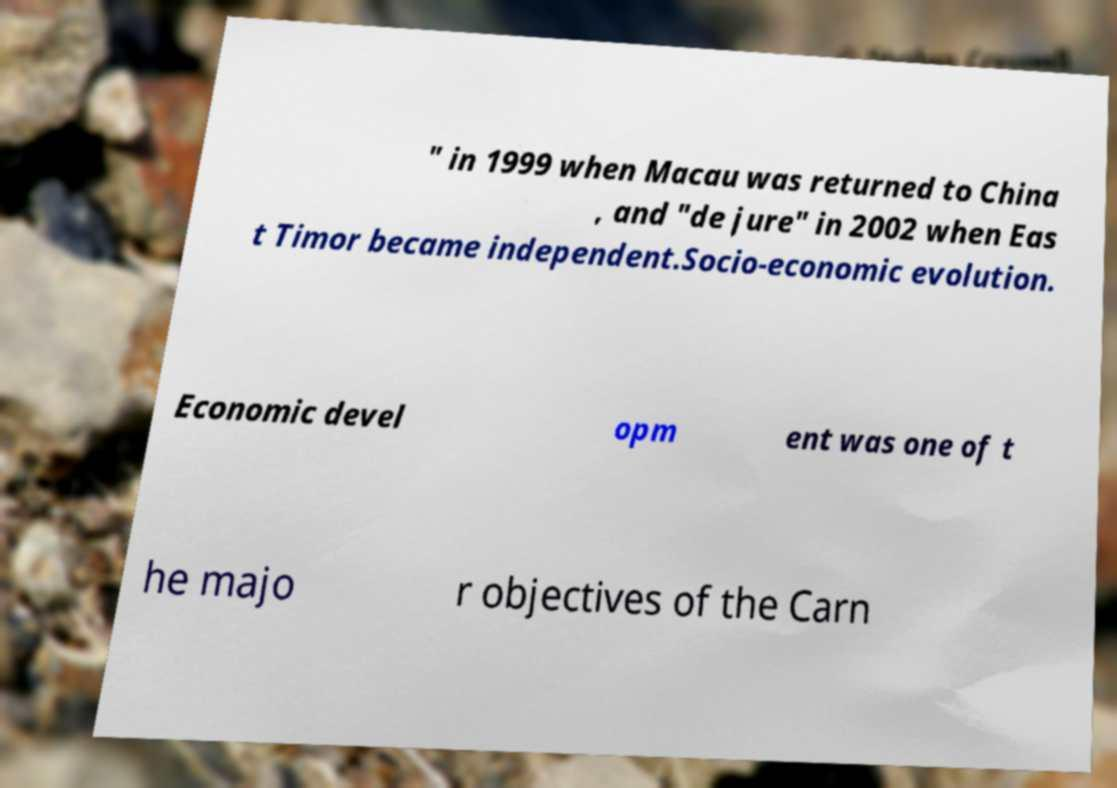Could you assist in decoding the text presented in this image and type it out clearly? " in 1999 when Macau was returned to China , and "de jure" in 2002 when Eas t Timor became independent.Socio-economic evolution. Economic devel opm ent was one of t he majo r objectives of the Carn 